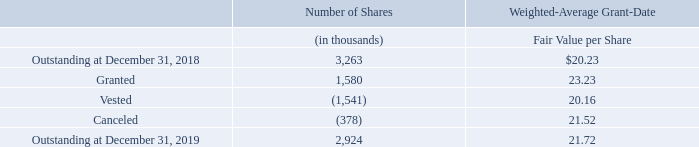Restricted Stock Units
A summary of the Company’s restricted stock unit activity is as follows:
Performance-Based Restricted Stock Units
Performance-based restricted stock units are eligible to vest at the end of each fiscal year in a three-year performance period based on the Company’s annual growth rate in net sales and non-GAAP diluted earnings per share (subject to certain adjustments) over a multiple of four times the related results for the fourth quarter of 2018 relative to the growth rates for a peer group of companies for the same metrics and periods.
For the performance-based restricted stock units granted in 2019, 60% of each performance-based award is subject to the net sales metric for the performance period and 40% is subject to the non-GAAP diluted earnings per share metric for the performance period. The maximum percentage for a particular metric is2 50% of the target number of units subject to the award related to that metric, however, vesting of the performance stock units is capped at 30% and 100%, respectively, of the target number of units subject to the award in years one and two, respectively, of the three-year performance period.
As of December 31, 2019, the Company believes that it is probable that the Company will achieve performance metrics specified in the award agreement based on its expected revenue and non-GAAP diluted EPS results over the performance period and calculated growth rates relative to its peers’ expected results based on data available, as defined in the award agreement.
What is the eligibility of Performance-based restricted stock to vest? At the end of each fiscal year in a three-year performance period based on the company’s annual growth rate. What was the number of shares Outstanding at December 31, 2018?
Answer scale should be: thousand. 3,263. What was the number of shares granted in 2019?
Answer scale should be: thousand. 1,580. What was the change in the outstanding from 2018 to 2019?
Answer scale should be: thousand. 2,924 - 3,263
Answer: -339. What percentage of outstanding at 2019 was granted?
Answer scale should be: percent. 1,580 / 2,924
Answer: 54.04. What is the average vested and canceled in 2019?
Answer scale should be: thousand. -(1,541 + 378) / 2
Answer: -959.5. 